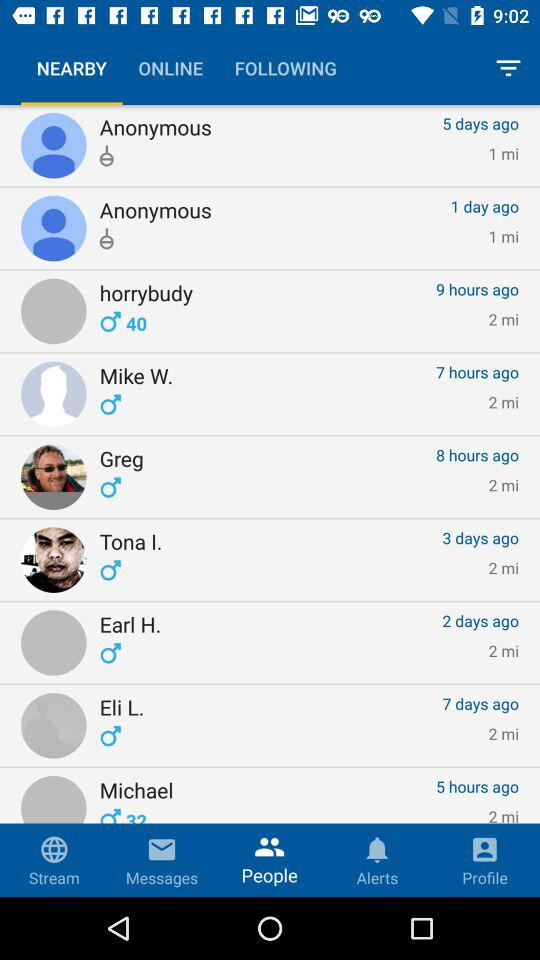Which tab is selected? The selected tabs are "NEARBY" and "People". 